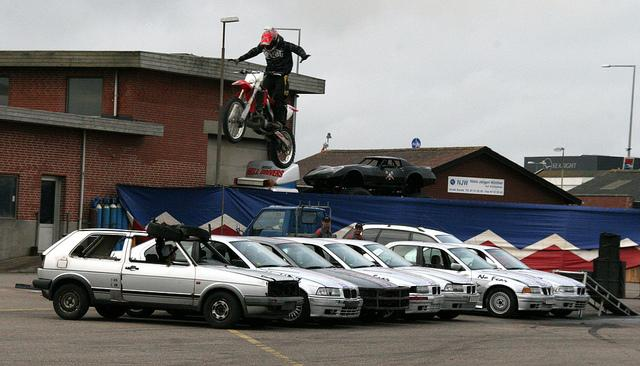Why is he in midair?

Choices:
A) broken wheells
B) showing off
C) he fell
D) bounced there showing off 